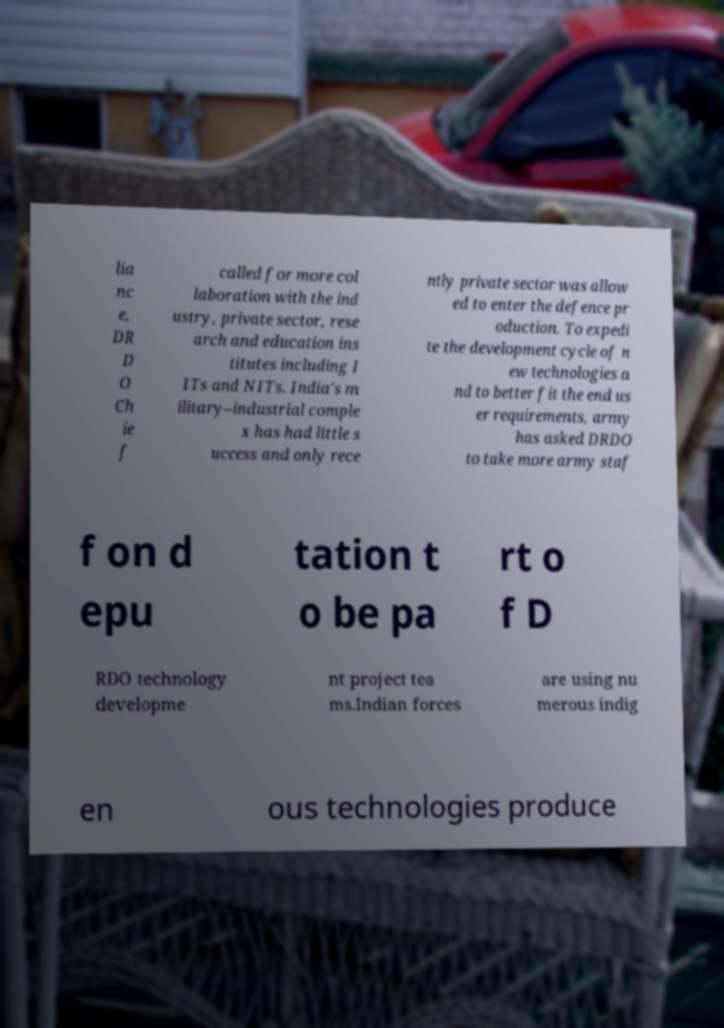What messages or text are displayed in this image? I need them in a readable, typed format. lia nc e, DR D O Ch ie f called for more col laboration with the ind ustry, private sector, rese arch and education ins titutes including I ITs and NITs. India's m ilitary–industrial comple x has had little s uccess and only rece ntly private sector was allow ed to enter the defence pr oduction. To expedi te the development cycle of n ew technologies a nd to better fit the end us er requirements, army has asked DRDO to take more army staf f on d epu tation t o be pa rt o f D RDO technology developme nt project tea ms.Indian forces are using nu merous indig en ous technologies produce 